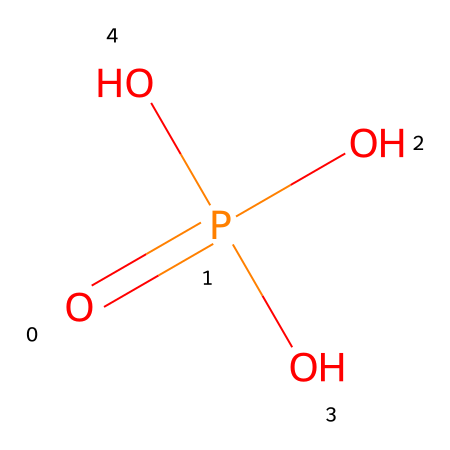What is the chemical name of the compound represented by this SMILES? The SMILES O=P(O)(O)O corresponds to phosphoric acid. The phosphorus atom (P) is bonded to four oxygen atoms (O), three of which are hydroxyl groups, indicating it is an acid.
Answer: phosphoric acid How many oxygen atoms are present in this compound? The SMILES shows four oxygen atoms connected to the phosphorus atom. By counting the 'O' symbols in the SMILES, we find a total of four.
Answer: 4 What is the oxidation state of phosphorus in this compound? In phosphoric acid, phosphorus (P) is bonded to four oxygens, and to balance the charge of three hydroxyl groups (–OH), the oxidation state of phosphorus is +5.
Answer: +5 How many hydroxyl groups are present in this compound? The SMILES indicates that there are three hydroxyl groups (-OH), which are represented by the (O) terms attached to the phosphorus atom.
Answer: 3 What type of bond connects phosphorus to oxygen in this structure? The bonds between phosphorus and oxygen in the structure includes one double bond (O=P) and three single bonds (P-O), indicating that phosphorus is capable of forming multiple types of bonds with oxygen.
Answer: multiple types of bonds What role does phosphoric acid play in photographic film emulsions? Phosphoric acid may serve as a buffering agent and stabilizer, helping to maintain the pH balance required for proper development of the film, thus playing a crucial role in the photographic process.
Answer: buffering agent 